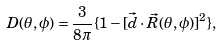<formula> <loc_0><loc_0><loc_500><loc_500>D ( \theta , \phi ) = \frac { 3 } { 8 \pi } \{ 1 - [ \vec { d } \cdot \vec { R } ( \theta , \phi ) ] ^ { 2 } \} ,</formula> 